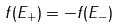Convert formula to latex. <formula><loc_0><loc_0><loc_500><loc_500>f ( E _ { + } ) = - f ( E _ { - } )</formula> 